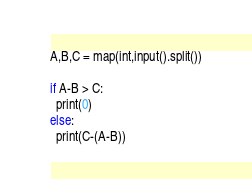Convert code to text. <code><loc_0><loc_0><loc_500><loc_500><_Python_>A,B,C = map(int,input().split())

if A-B > C:
  print(0)
else:
  print(C-(A-B))</code> 